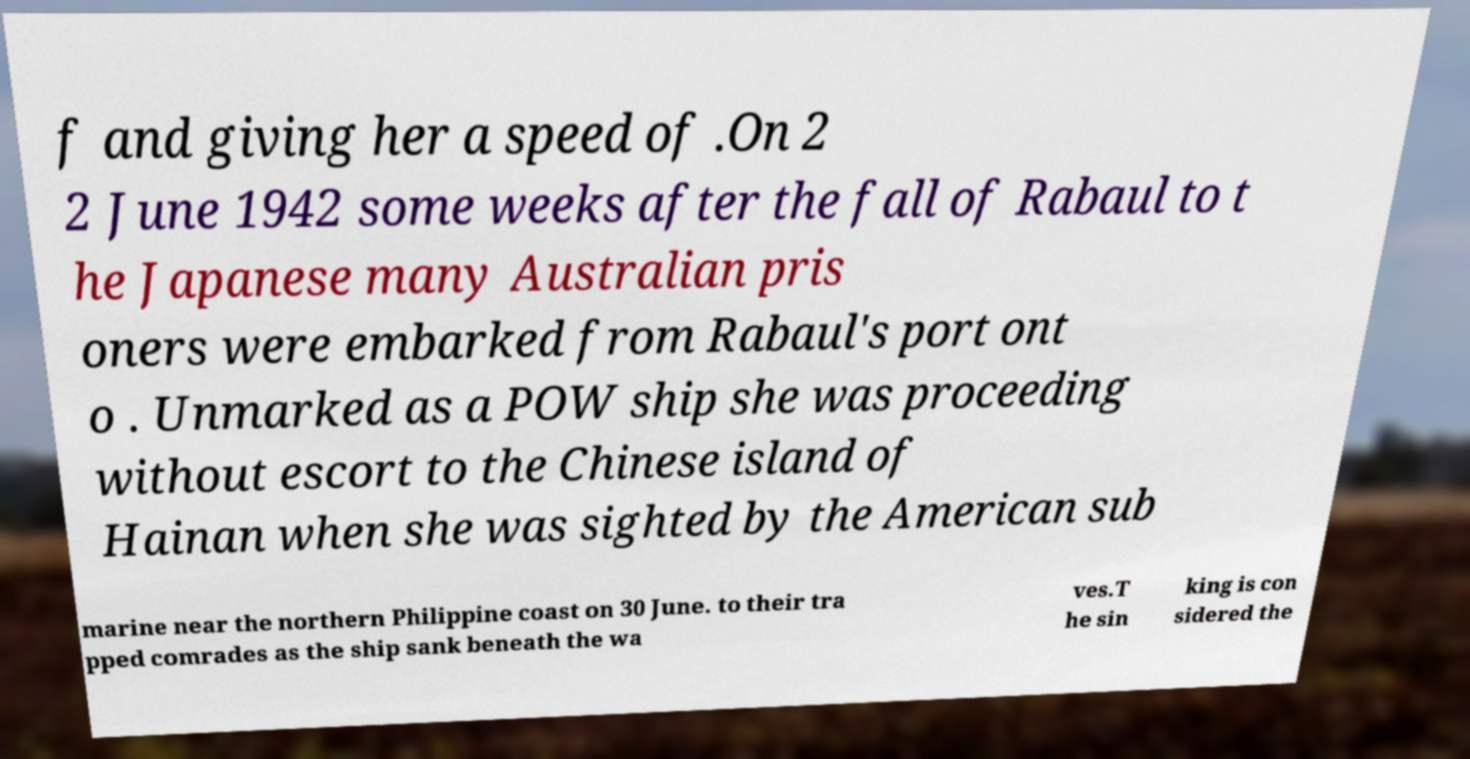What messages or text are displayed in this image? I need them in a readable, typed format. f and giving her a speed of .On 2 2 June 1942 some weeks after the fall of Rabaul to t he Japanese many Australian pris oners were embarked from Rabaul's port ont o . Unmarked as a POW ship she was proceeding without escort to the Chinese island of Hainan when she was sighted by the American sub marine near the northern Philippine coast on 30 June. to their tra pped comrades as the ship sank beneath the wa ves.T he sin king is con sidered the 